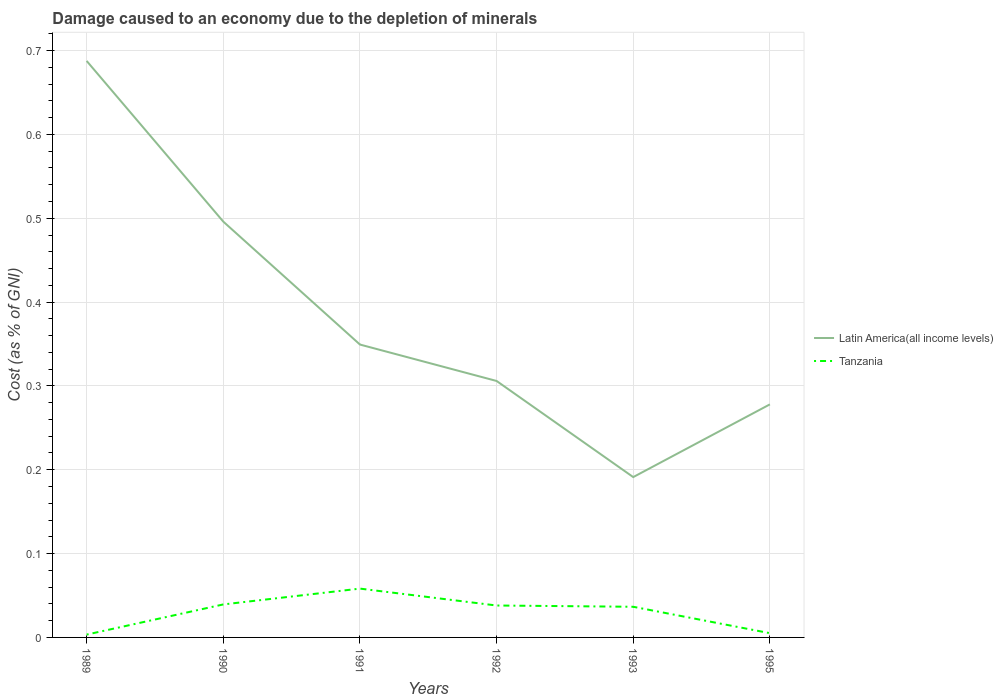How many different coloured lines are there?
Keep it short and to the point. 2. Does the line corresponding to Latin America(all income levels) intersect with the line corresponding to Tanzania?
Provide a succinct answer. No. Is the number of lines equal to the number of legend labels?
Your response must be concise. Yes. Across all years, what is the maximum cost of damage caused due to the depletion of minerals in Tanzania?
Offer a terse response. 0. In which year was the cost of damage caused due to the depletion of minerals in Latin America(all income levels) maximum?
Make the answer very short. 1993. What is the total cost of damage caused due to the depletion of minerals in Latin America(all income levels) in the graph?
Your answer should be very brief. 0.22. What is the difference between the highest and the second highest cost of damage caused due to the depletion of minerals in Latin America(all income levels)?
Keep it short and to the point. 0.5. Is the cost of damage caused due to the depletion of minerals in Latin America(all income levels) strictly greater than the cost of damage caused due to the depletion of minerals in Tanzania over the years?
Offer a terse response. No. How many lines are there?
Provide a succinct answer. 2. How many years are there in the graph?
Provide a succinct answer. 6. Are the values on the major ticks of Y-axis written in scientific E-notation?
Your response must be concise. No. Does the graph contain any zero values?
Offer a very short reply. No. Does the graph contain grids?
Your answer should be very brief. Yes. Where does the legend appear in the graph?
Keep it short and to the point. Center right. How many legend labels are there?
Provide a short and direct response. 2. What is the title of the graph?
Your answer should be very brief. Damage caused to an economy due to the depletion of minerals. What is the label or title of the Y-axis?
Provide a short and direct response. Cost (as % of GNI). What is the Cost (as % of GNI) in Latin America(all income levels) in 1989?
Offer a very short reply. 0.69. What is the Cost (as % of GNI) in Tanzania in 1989?
Your answer should be compact. 0. What is the Cost (as % of GNI) in Latin America(all income levels) in 1990?
Keep it short and to the point. 0.5. What is the Cost (as % of GNI) of Tanzania in 1990?
Your response must be concise. 0.04. What is the Cost (as % of GNI) of Latin America(all income levels) in 1991?
Your answer should be compact. 0.35. What is the Cost (as % of GNI) of Tanzania in 1991?
Offer a very short reply. 0.06. What is the Cost (as % of GNI) in Latin America(all income levels) in 1992?
Ensure brevity in your answer.  0.31. What is the Cost (as % of GNI) in Tanzania in 1992?
Your answer should be very brief. 0.04. What is the Cost (as % of GNI) in Latin America(all income levels) in 1993?
Offer a terse response. 0.19. What is the Cost (as % of GNI) in Tanzania in 1993?
Your response must be concise. 0.04. What is the Cost (as % of GNI) of Latin America(all income levels) in 1995?
Keep it short and to the point. 0.28. What is the Cost (as % of GNI) in Tanzania in 1995?
Provide a succinct answer. 0.01. Across all years, what is the maximum Cost (as % of GNI) of Latin America(all income levels)?
Your answer should be very brief. 0.69. Across all years, what is the maximum Cost (as % of GNI) of Tanzania?
Give a very brief answer. 0.06. Across all years, what is the minimum Cost (as % of GNI) of Latin America(all income levels)?
Offer a terse response. 0.19. Across all years, what is the minimum Cost (as % of GNI) of Tanzania?
Make the answer very short. 0. What is the total Cost (as % of GNI) of Latin America(all income levels) in the graph?
Offer a terse response. 2.31. What is the total Cost (as % of GNI) in Tanzania in the graph?
Ensure brevity in your answer.  0.18. What is the difference between the Cost (as % of GNI) of Latin America(all income levels) in 1989 and that in 1990?
Your answer should be very brief. 0.19. What is the difference between the Cost (as % of GNI) of Tanzania in 1989 and that in 1990?
Provide a short and direct response. -0.04. What is the difference between the Cost (as % of GNI) in Latin America(all income levels) in 1989 and that in 1991?
Your answer should be very brief. 0.34. What is the difference between the Cost (as % of GNI) in Tanzania in 1989 and that in 1991?
Provide a succinct answer. -0.05. What is the difference between the Cost (as % of GNI) of Latin America(all income levels) in 1989 and that in 1992?
Give a very brief answer. 0.38. What is the difference between the Cost (as % of GNI) of Tanzania in 1989 and that in 1992?
Your answer should be very brief. -0.03. What is the difference between the Cost (as % of GNI) of Latin America(all income levels) in 1989 and that in 1993?
Make the answer very short. 0.5. What is the difference between the Cost (as % of GNI) in Tanzania in 1989 and that in 1993?
Offer a very short reply. -0.03. What is the difference between the Cost (as % of GNI) of Latin America(all income levels) in 1989 and that in 1995?
Provide a succinct answer. 0.41. What is the difference between the Cost (as % of GNI) of Tanzania in 1989 and that in 1995?
Keep it short and to the point. -0. What is the difference between the Cost (as % of GNI) of Latin America(all income levels) in 1990 and that in 1991?
Keep it short and to the point. 0.15. What is the difference between the Cost (as % of GNI) of Tanzania in 1990 and that in 1991?
Provide a short and direct response. -0.02. What is the difference between the Cost (as % of GNI) in Latin America(all income levels) in 1990 and that in 1992?
Provide a short and direct response. 0.19. What is the difference between the Cost (as % of GNI) of Tanzania in 1990 and that in 1992?
Offer a very short reply. 0. What is the difference between the Cost (as % of GNI) of Latin America(all income levels) in 1990 and that in 1993?
Keep it short and to the point. 0.3. What is the difference between the Cost (as % of GNI) in Tanzania in 1990 and that in 1993?
Make the answer very short. 0. What is the difference between the Cost (as % of GNI) in Latin America(all income levels) in 1990 and that in 1995?
Offer a terse response. 0.22. What is the difference between the Cost (as % of GNI) in Tanzania in 1990 and that in 1995?
Offer a terse response. 0.03. What is the difference between the Cost (as % of GNI) of Latin America(all income levels) in 1991 and that in 1992?
Offer a terse response. 0.04. What is the difference between the Cost (as % of GNI) in Tanzania in 1991 and that in 1992?
Your answer should be compact. 0.02. What is the difference between the Cost (as % of GNI) in Latin America(all income levels) in 1991 and that in 1993?
Offer a very short reply. 0.16. What is the difference between the Cost (as % of GNI) in Tanzania in 1991 and that in 1993?
Your response must be concise. 0.02. What is the difference between the Cost (as % of GNI) of Latin America(all income levels) in 1991 and that in 1995?
Keep it short and to the point. 0.07. What is the difference between the Cost (as % of GNI) in Tanzania in 1991 and that in 1995?
Provide a succinct answer. 0.05. What is the difference between the Cost (as % of GNI) in Latin America(all income levels) in 1992 and that in 1993?
Provide a short and direct response. 0.11. What is the difference between the Cost (as % of GNI) in Tanzania in 1992 and that in 1993?
Provide a short and direct response. 0. What is the difference between the Cost (as % of GNI) of Latin America(all income levels) in 1992 and that in 1995?
Offer a very short reply. 0.03. What is the difference between the Cost (as % of GNI) of Tanzania in 1992 and that in 1995?
Your answer should be compact. 0.03. What is the difference between the Cost (as % of GNI) in Latin America(all income levels) in 1993 and that in 1995?
Ensure brevity in your answer.  -0.09. What is the difference between the Cost (as % of GNI) in Tanzania in 1993 and that in 1995?
Provide a short and direct response. 0.03. What is the difference between the Cost (as % of GNI) of Latin America(all income levels) in 1989 and the Cost (as % of GNI) of Tanzania in 1990?
Provide a succinct answer. 0.65. What is the difference between the Cost (as % of GNI) of Latin America(all income levels) in 1989 and the Cost (as % of GNI) of Tanzania in 1991?
Your answer should be very brief. 0.63. What is the difference between the Cost (as % of GNI) of Latin America(all income levels) in 1989 and the Cost (as % of GNI) of Tanzania in 1992?
Give a very brief answer. 0.65. What is the difference between the Cost (as % of GNI) of Latin America(all income levels) in 1989 and the Cost (as % of GNI) of Tanzania in 1993?
Offer a very short reply. 0.65. What is the difference between the Cost (as % of GNI) in Latin America(all income levels) in 1989 and the Cost (as % of GNI) in Tanzania in 1995?
Offer a very short reply. 0.68. What is the difference between the Cost (as % of GNI) in Latin America(all income levels) in 1990 and the Cost (as % of GNI) in Tanzania in 1991?
Give a very brief answer. 0.44. What is the difference between the Cost (as % of GNI) of Latin America(all income levels) in 1990 and the Cost (as % of GNI) of Tanzania in 1992?
Your answer should be very brief. 0.46. What is the difference between the Cost (as % of GNI) of Latin America(all income levels) in 1990 and the Cost (as % of GNI) of Tanzania in 1993?
Your answer should be compact. 0.46. What is the difference between the Cost (as % of GNI) of Latin America(all income levels) in 1990 and the Cost (as % of GNI) of Tanzania in 1995?
Offer a terse response. 0.49. What is the difference between the Cost (as % of GNI) in Latin America(all income levels) in 1991 and the Cost (as % of GNI) in Tanzania in 1992?
Keep it short and to the point. 0.31. What is the difference between the Cost (as % of GNI) in Latin America(all income levels) in 1991 and the Cost (as % of GNI) in Tanzania in 1993?
Ensure brevity in your answer.  0.31. What is the difference between the Cost (as % of GNI) in Latin America(all income levels) in 1991 and the Cost (as % of GNI) in Tanzania in 1995?
Keep it short and to the point. 0.34. What is the difference between the Cost (as % of GNI) of Latin America(all income levels) in 1992 and the Cost (as % of GNI) of Tanzania in 1993?
Keep it short and to the point. 0.27. What is the difference between the Cost (as % of GNI) in Latin America(all income levels) in 1992 and the Cost (as % of GNI) in Tanzania in 1995?
Offer a terse response. 0.3. What is the difference between the Cost (as % of GNI) of Latin America(all income levels) in 1993 and the Cost (as % of GNI) of Tanzania in 1995?
Give a very brief answer. 0.19. What is the average Cost (as % of GNI) in Latin America(all income levels) per year?
Your answer should be very brief. 0.38. What is the average Cost (as % of GNI) in Tanzania per year?
Offer a terse response. 0.03. In the year 1989, what is the difference between the Cost (as % of GNI) of Latin America(all income levels) and Cost (as % of GNI) of Tanzania?
Offer a very short reply. 0.68. In the year 1990, what is the difference between the Cost (as % of GNI) of Latin America(all income levels) and Cost (as % of GNI) of Tanzania?
Make the answer very short. 0.46. In the year 1991, what is the difference between the Cost (as % of GNI) of Latin America(all income levels) and Cost (as % of GNI) of Tanzania?
Your answer should be compact. 0.29. In the year 1992, what is the difference between the Cost (as % of GNI) of Latin America(all income levels) and Cost (as % of GNI) of Tanzania?
Give a very brief answer. 0.27. In the year 1993, what is the difference between the Cost (as % of GNI) in Latin America(all income levels) and Cost (as % of GNI) in Tanzania?
Your answer should be very brief. 0.15. In the year 1995, what is the difference between the Cost (as % of GNI) of Latin America(all income levels) and Cost (as % of GNI) of Tanzania?
Ensure brevity in your answer.  0.27. What is the ratio of the Cost (as % of GNI) in Latin America(all income levels) in 1989 to that in 1990?
Make the answer very short. 1.39. What is the ratio of the Cost (as % of GNI) in Tanzania in 1989 to that in 1990?
Offer a terse response. 0.09. What is the ratio of the Cost (as % of GNI) of Latin America(all income levels) in 1989 to that in 1991?
Provide a short and direct response. 1.97. What is the ratio of the Cost (as % of GNI) in Tanzania in 1989 to that in 1991?
Your answer should be compact. 0.06. What is the ratio of the Cost (as % of GNI) of Latin America(all income levels) in 1989 to that in 1992?
Provide a short and direct response. 2.25. What is the ratio of the Cost (as % of GNI) of Tanzania in 1989 to that in 1992?
Give a very brief answer. 0.09. What is the ratio of the Cost (as % of GNI) of Latin America(all income levels) in 1989 to that in 1993?
Give a very brief answer. 3.6. What is the ratio of the Cost (as % of GNI) of Tanzania in 1989 to that in 1993?
Your response must be concise. 0.09. What is the ratio of the Cost (as % of GNI) of Latin America(all income levels) in 1989 to that in 1995?
Your answer should be very brief. 2.47. What is the ratio of the Cost (as % of GNI) in Tanzania in 1989 to that in 1995?
Keep it short and to the point. 0.66. What is the ratio of the Cost (as % of GNI) of Latin America(all income levels) in 1990 to that in 1991?
Keep it short and to the point. 1.42. What is the ratio of the Cost (as % of GNI) of Tanzania in 1990 to that in 1991?
Your response must be concise. 0.68. What is the ratio of the Cost (as % of GNI) of Latin America(all income levels) in 1990 to that in 1992?
Provide a short and direct response. 1.62. What is the ratio of the Cost (as % of GNI) of Tanzania in 1990 to that in 1992?
Provide a succinct answer. 1.03. What is the ratio of the Cost (as % of GNI) in Latin America(all income levels) in 1990 to that in 1993?
Keep it short and to the point. 2.59. What is the ratio of the Cost (as % of GNI) in Tanzania in 1990 to that in 1993?
Provide a short and direct response. 1.08. What is the ratio of the Cost (as % of GNI) of Latin America(all income levels) in 1990 to that in 1995?
Your response must be concise. 1.78. What is the ratio of the Cost (as % of GNI) of Tanzania in 1990 to that in 1995?
Your answer should be compact. 7.75. What is the ratio of the Cost (as % of GNI) in Latin America(all income levels) in 1991 to that in 1992?
Your answer should be very brief. 1.14. What is the ratio of the Cost (as % of GNI) in Tanzania in 1991 to that in 1992?
Offer a very short reply. 1.53. What is the ratio of the Cost (as % of GNI) in Latin America(all income levels) in 1991 to that in 1993?
Keep it short and to the point. 1.83. What is the ratio of the Cost (as % of GNI) of Tanzania in 1991 to that in 1993?
Make the answer very short. 1.59. What is the ratio of the Cost (as % of GNI) of Latin America(all income levels) in 1991 to that in 1995?
Your answer should be very brief. 1.26. What is the ratio of the Cost (as % of GNI) of Tanzania in 1991 to that in 1995?
Offer a very short reply. 11.47. What is the ratio of the Cost (as % of GNI) of Latin America(all income levels) in 1992 to that in 1993?
Keep it short and to the point. 1.6. What is the ratio of the Cost (as % of GNI) in Tanzania in 1992 to that in 1993?
Offer a terse response. 1.04. What is the ratio of the Cost (as % of GNI) in Latin America(all income levels) in 1992 to that in 1995?
Give a very brief answer. 1.1. What is the ratio of the Cost (as % of GNI) of Tanzania in 1992 to that in 1995?
Your answer should be compact. 7.5. What is the ratio of the Cost (as % of GNI) of Latin America(all income levels) in 1993 to that in 1995?
Your answer should be very brief. 0.69. What is the ratio of the Cost (as % of GNI) in Tanzania in 1993 to that in 1995?
Give a very brief answer. 7.2. What is the difference between the highest and the second highest Cost (as % of GNI) of Latin America(all income levels)?
Provide a succinct answer. 0.19. What is the difference between the highest and the second highest Cost (as % of GNI) of Tanzania?
Your response must be concise. 0.02. What is the difference between the highest and the lowest Cost (as % of GNI) of Latin America(all income levels)?
Give a very brief answer. 0.5. What is the difference between the highest and the lowest Cost (as % of GNI) in Tanzania?
Your response must be concise. 0.05. 